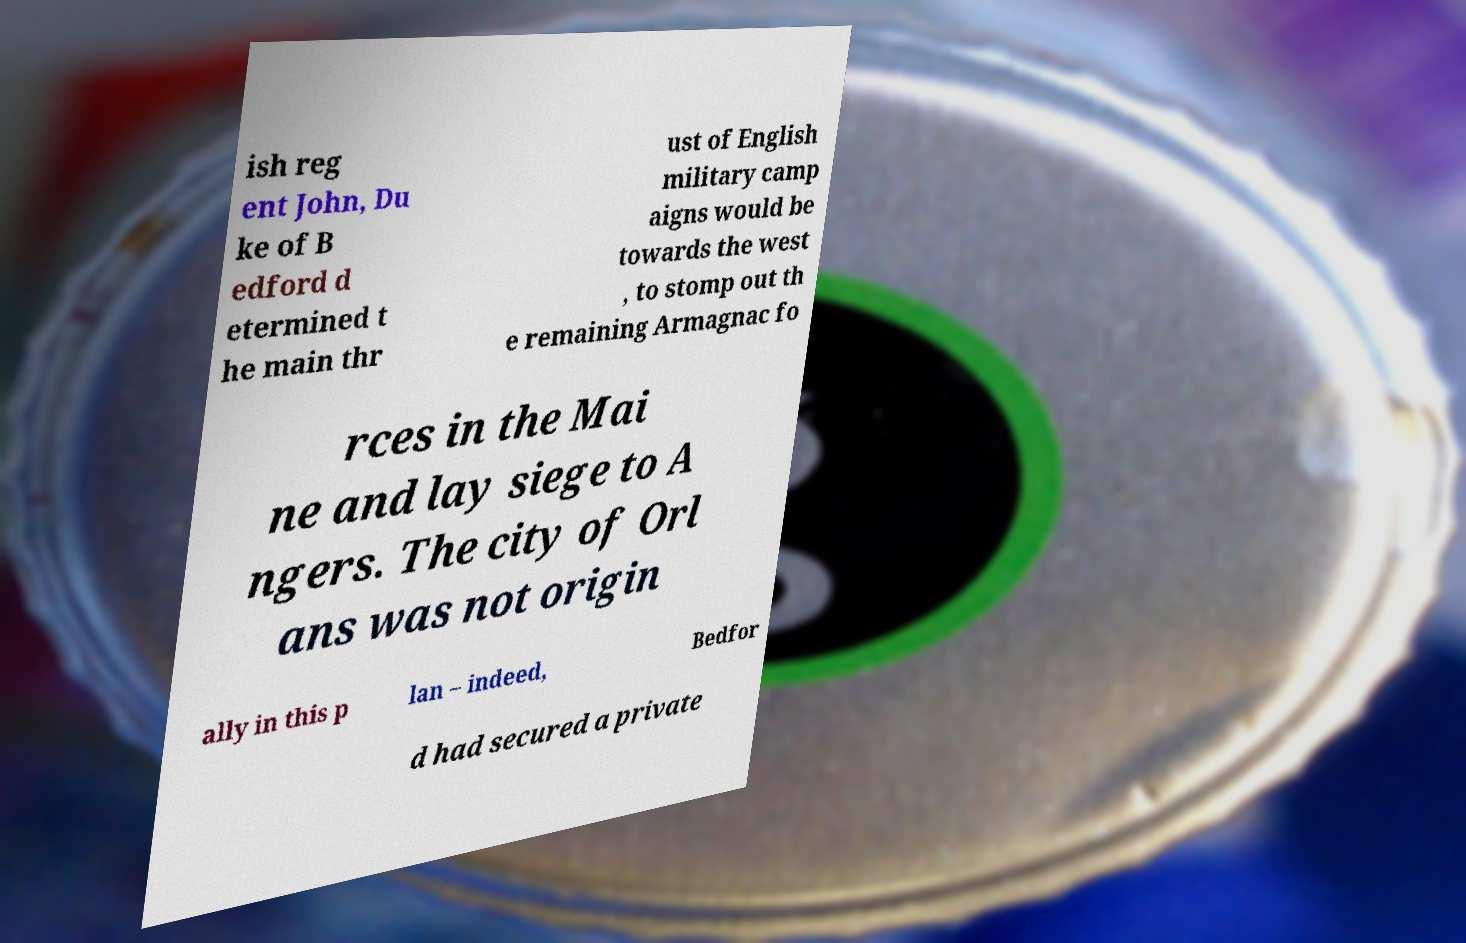Could you extract and type out the text from this image? ish reg ent John, Du ke of B edford d etermined t he main thr ust of English military camp aigns would be towards the west , to stomp out th e remaining Armagnac fo rces in the Mai ne and lay siege to A ngers. The city of Orl ans was not origin ally in this p lan – indeed, Bedfor d had secured a private 